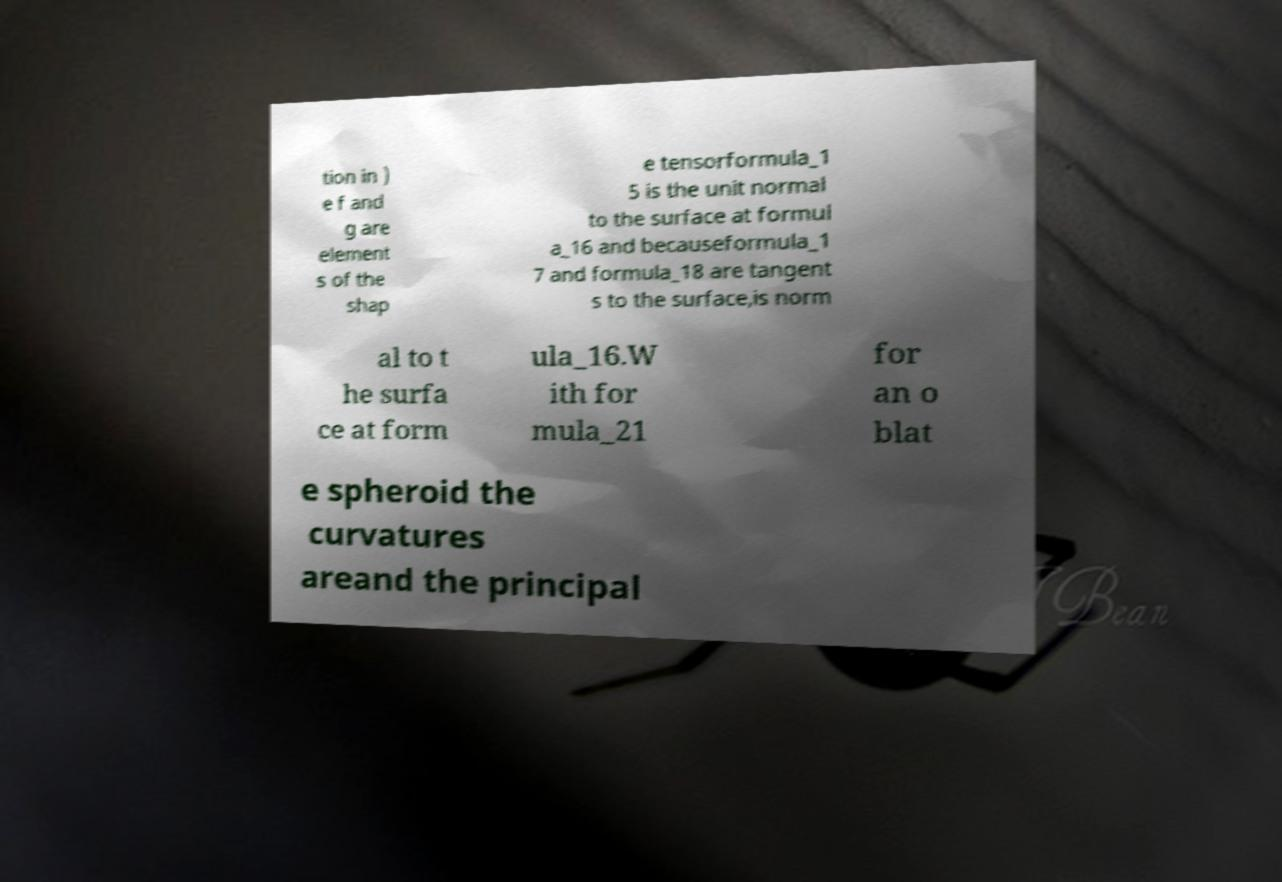I need the written content from this picture converted into text. Can you do that? tion in ) e f and g are element s of the shap e tensorformula_1 5 is the unit normal to the surface at formul a_16 and becauseformula_1 7 and formula_18 are tangent s to the surface,is norm al to t he surfa ce at form ula_16.W ith for mula_21 for an o blat e spheroid the curvatures areand the principal 